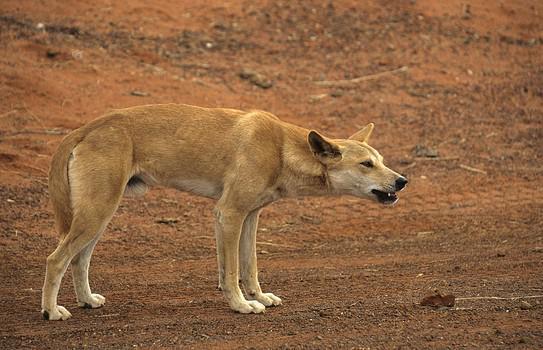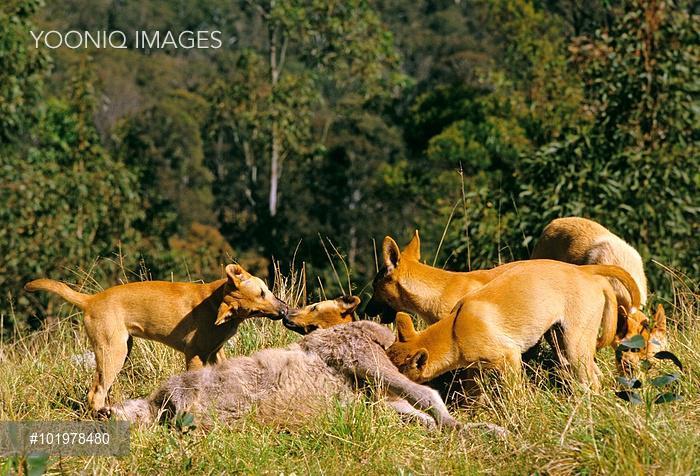The first image is the image on the left, the second image is the image on the right. Assess this claim about the two images: "One of the dingo images includes a natural body of water, and the other features a dog standing upright in the foreground.". Correct or not? Answer yes or no. No. 